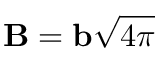Convert formula to latex. <formula><loc_0><loc_0><loc_500><loc_500>{ B } = { b } \sqrt { 4 \pi }</formula> 